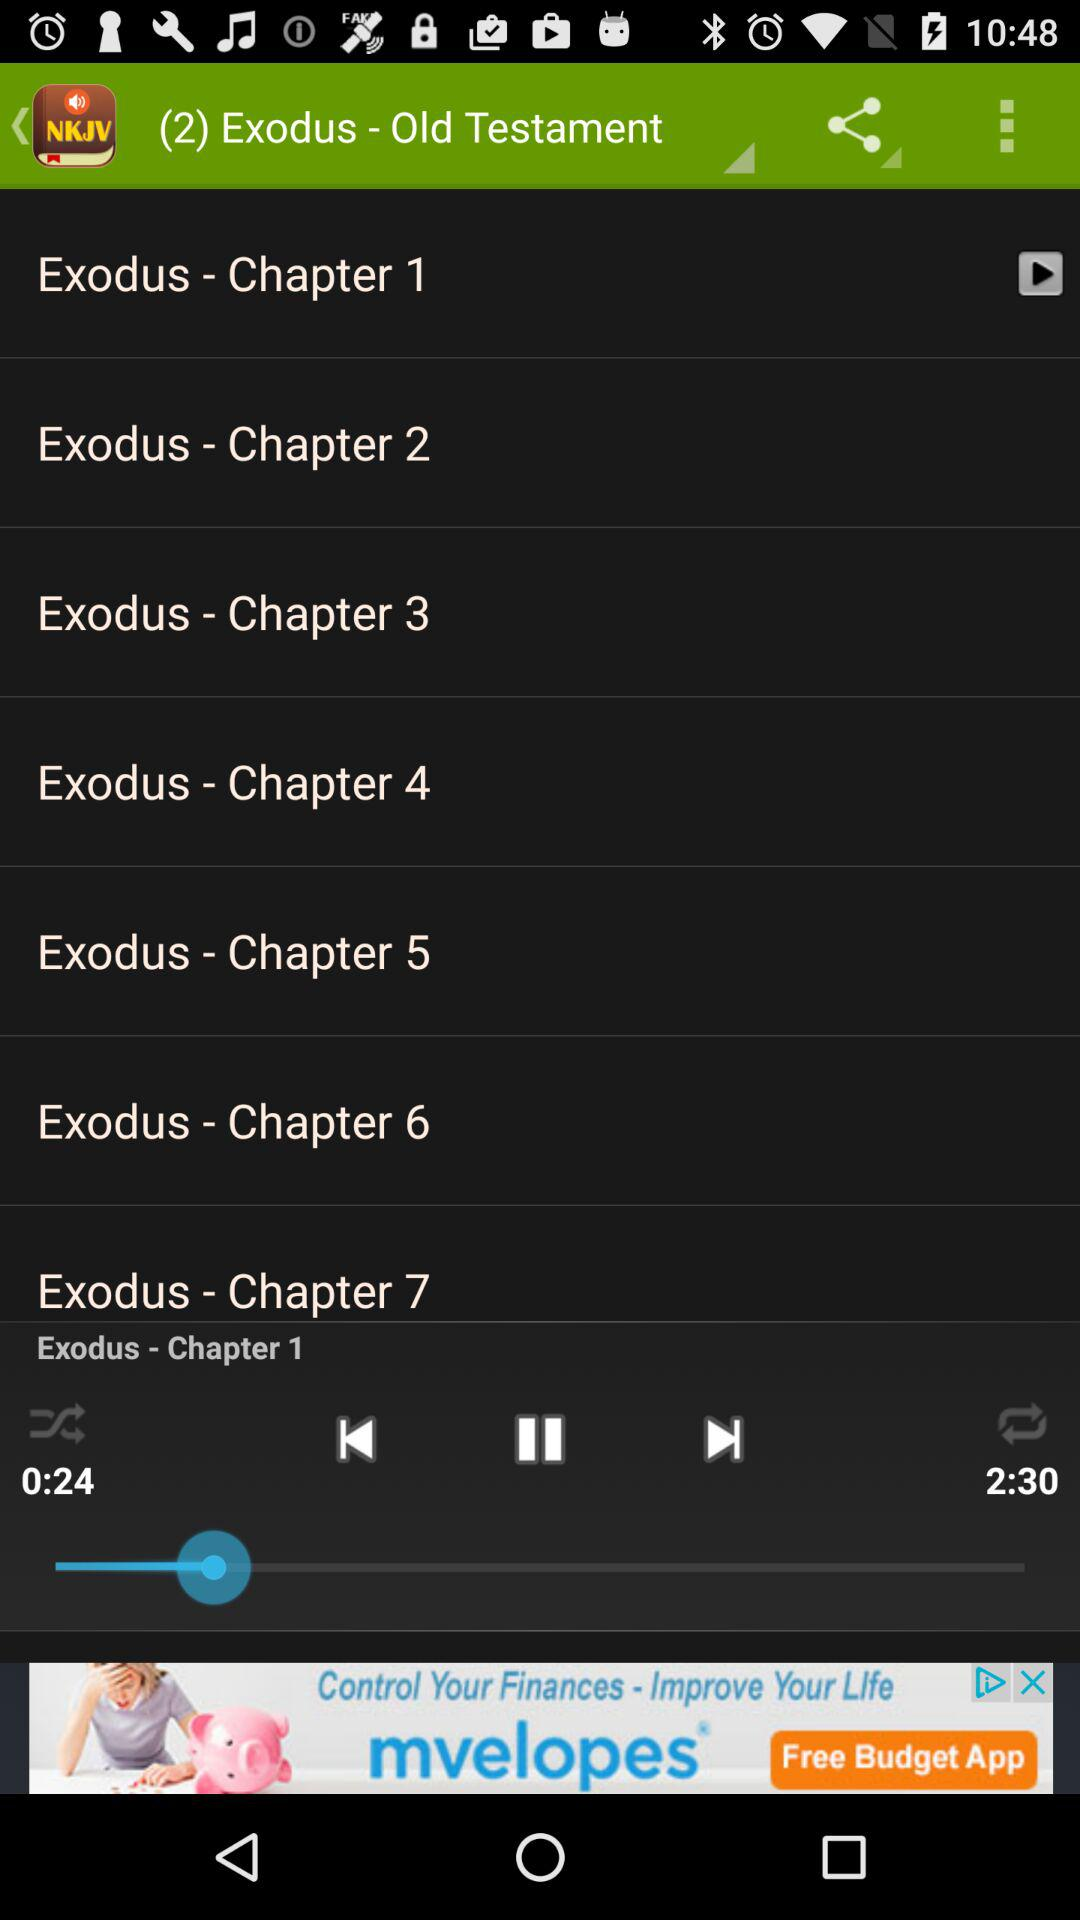For how long "Exodus - Chapter 1" has been played? "Exodus - Chapter 1" has been played for 24 seconds. 